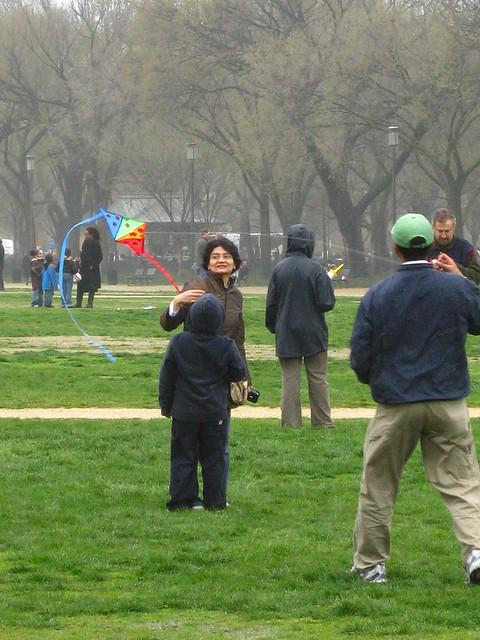Who is steering the flying object?

Choices:
A) man
B) boy
C) girl
D) woman man 